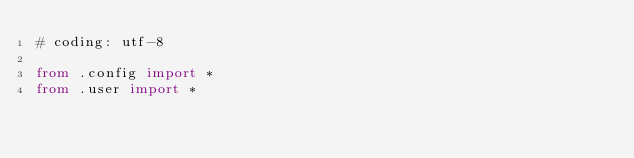<code> <loc_0><loc_0><loc_500><loc_500><_Python_># coding: utf-8

from .config import *
from .user import *
</code> 